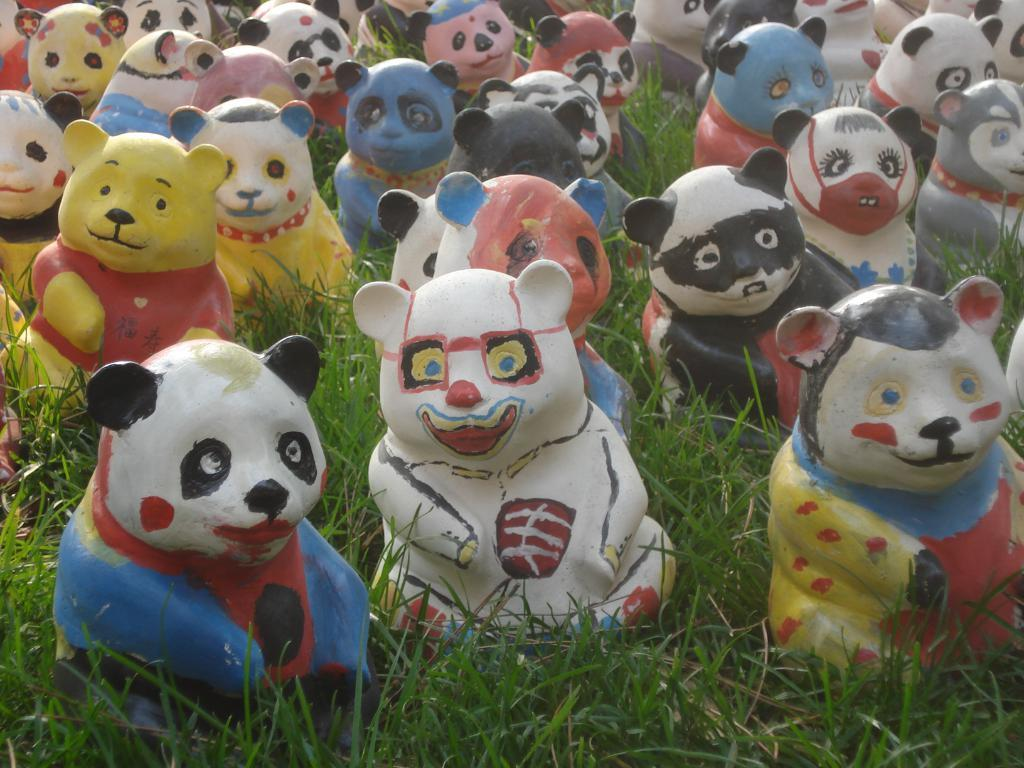What types of objects are present in the image? There are different colored toys in the image. What type of natural environment is visible in the image? There is grass visible in the image. What type of respect can be seen being given to the door in the image? There is no door present in the image, so it is not possible to determine if any respect is being given to a door. 